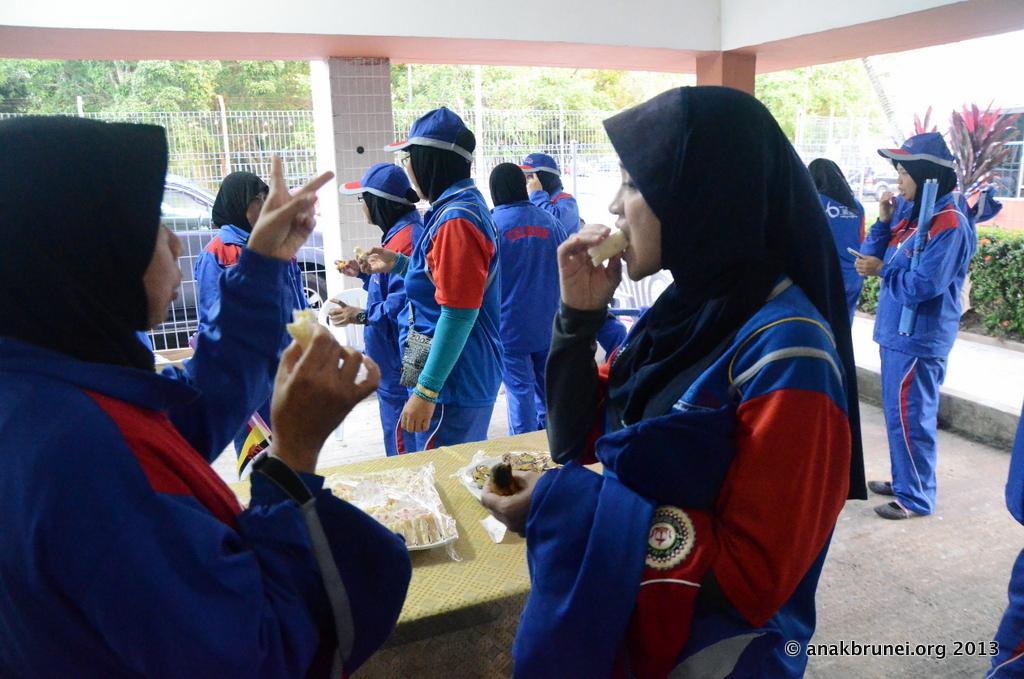How would you summarize this image in a sentence or two? In this image I can see some people. In the background, I can see a car, the rail and the trees. 